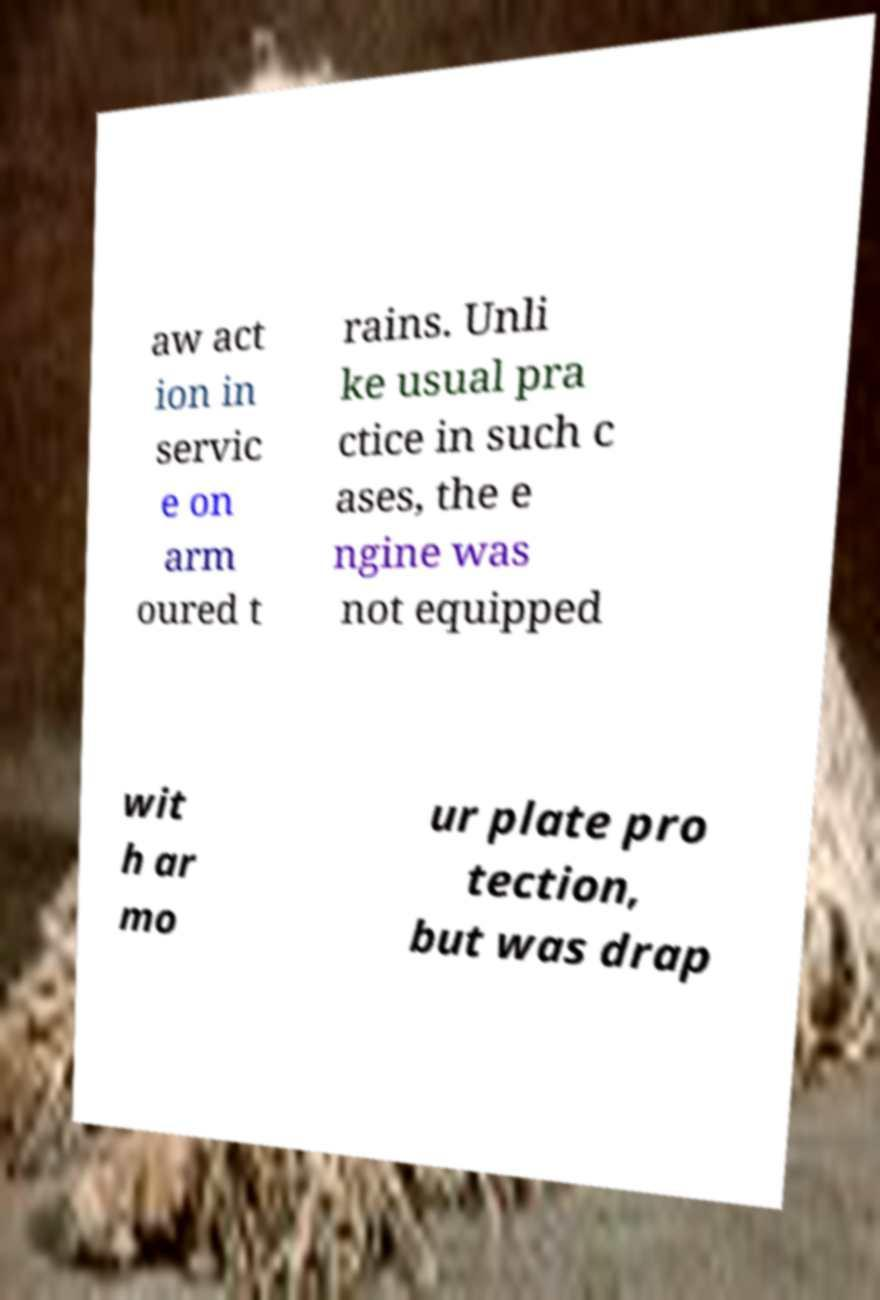Could you assist in decoding the text presented in this image and type it out clearly? aw act ion in servic e on arm oured t rains. Unli ke usual pra ctice in such c ases, the e ngine was not equipped wit h ar mo ur plate pro tection, but was drap 